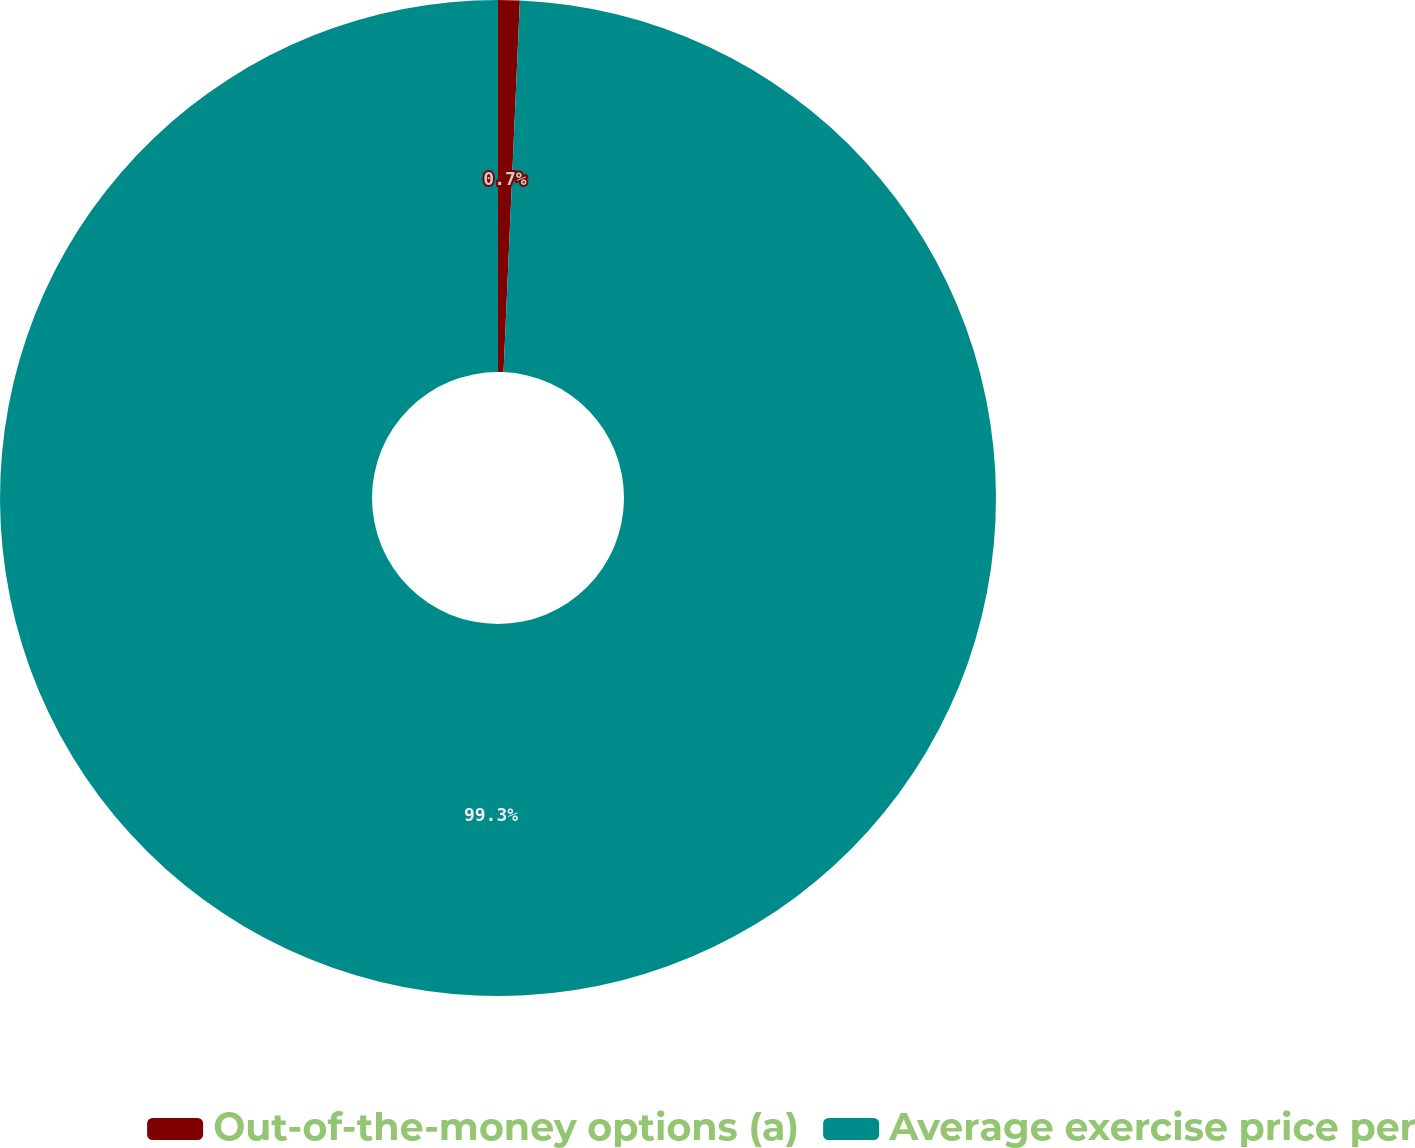<chart> <loc_0><loc_0><loc_500><loc_500><pie_chart><fcel>Out-of-the-money options (a)<fcel>Average exercise price per<nl><fcel>0.7%<fcel>99.3%<nl></chart> 